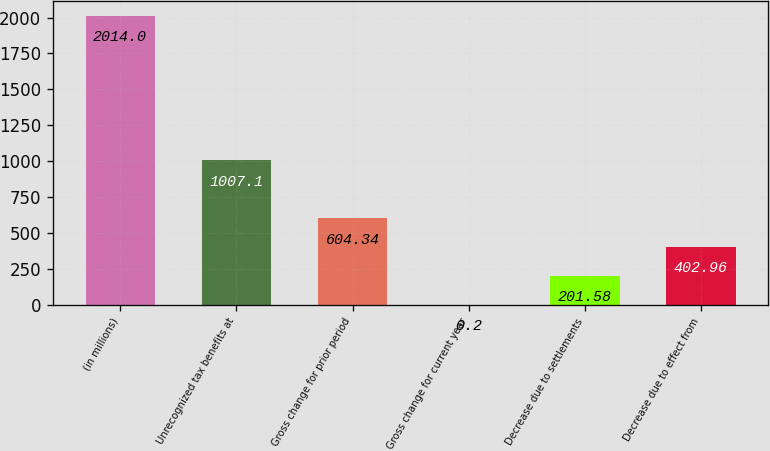Convert chart. <chart><loc_0><loc_0><loc_500><loc_500><bar_chart><fcel>(in millions)<fcel>Unrecognized tax benefits at<fcel>Gross change for prior period<fcel>Gross change for current year<fcel>Decrease due to settlements<fcel>Decrease due to effect from<nl><fcel>2014<fcel>1007.1<fcel>604.34<fcel>0.2<fcel>201.58<fcel>402.96<nl></chart> 